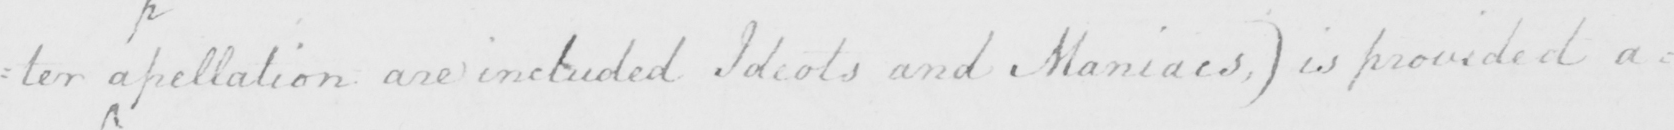What text is written in this handwritten line? : ter a pellation are included Ideots and Maniacs , )  is provided a= 